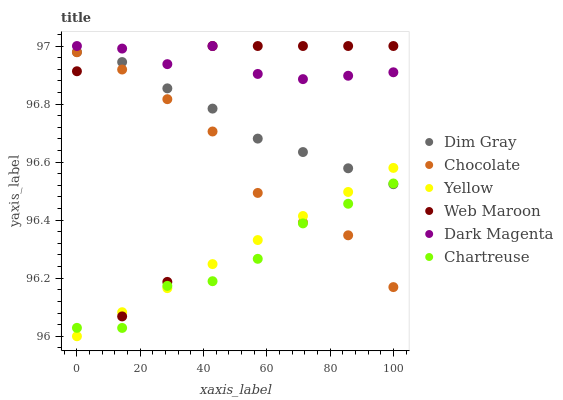Does Chartreuse have the minimum area under the curve?
Answer yes or no. Yes. Does Dark Magenta have the maximum area under the curve?
Answer yes or no. Yes. Does Web Maroon have the minimum area under the curve?
Answer yes or no. No. Does Web Maroon have the maximum area under the curve?
Answer yes or no. No. Is Yellow the smoothest?
Answer yes or no. Yes. Is Web Maroon the roughest?
Answer yes or no. Yes. Is Dark Magenta the smoothest?
Answer yes or no. No. Is Dark Magenta the roughest?
Answer yes or no. No. Does Yellow have the lowest value?
Answer yes or no. Yes. Does Web Maroon have the lowest value?
Answer yes or no. No. Does Web Maroon have the highest value?
Answer yes or no. Yes. Does Yellow have the highest value?
Answer yes or no. No. Is Dim Gray less than Dark Magenta?
Answer yes or no. Yes. Is Web Maroon greater than Chartreuse?
Answer yes or no. Yes. Does Dim Gray intersect Yellow?
Answer yes or no. Yes. Is Dim Gray less than Yellow?
Answer yes or no. No. Is Dim Gray greater than Yellow?
Answer yes or no. No. Does Dim Gray intersect Dark Magenta?
Answer yes or no. No. 